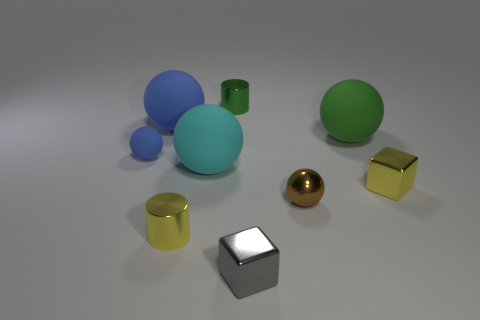Subtract all small blue balls. How many balls are left? 4 Subtract 1 balls. How many balls are left? 4 Subtract all green spheres. How many spheres are left? 4 Subtract all purple cylinders. Subtract all gray balls. How many cylinders are left? 2 Add 1 yellow shiny cubes. How many objects exist? 10 Subtract all spheres. How many objects are left? 4 Subtract 0 red cylinders. How many objects are left? 9 Subtract all tiny gray objects. Subtract all tiny green cylinders. How many objects are left? 7 Add 4 small metal spheres. How many small metal spheres are left? 5 Add 8 large purple cubes. How many large purple cubes exist? 8 